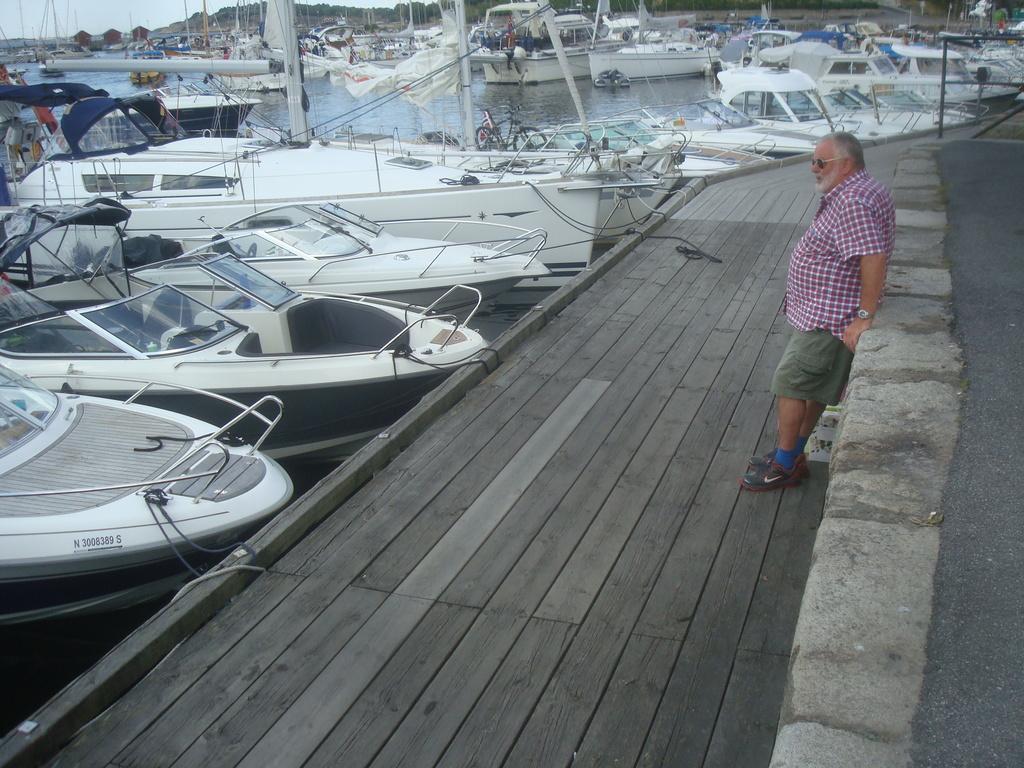How would you summarize this image in a sentence or two? In the right side a man is standing, he wore a shirt, short. In the left side few boats are parked which are in white color and this is water in the middle of an image. 